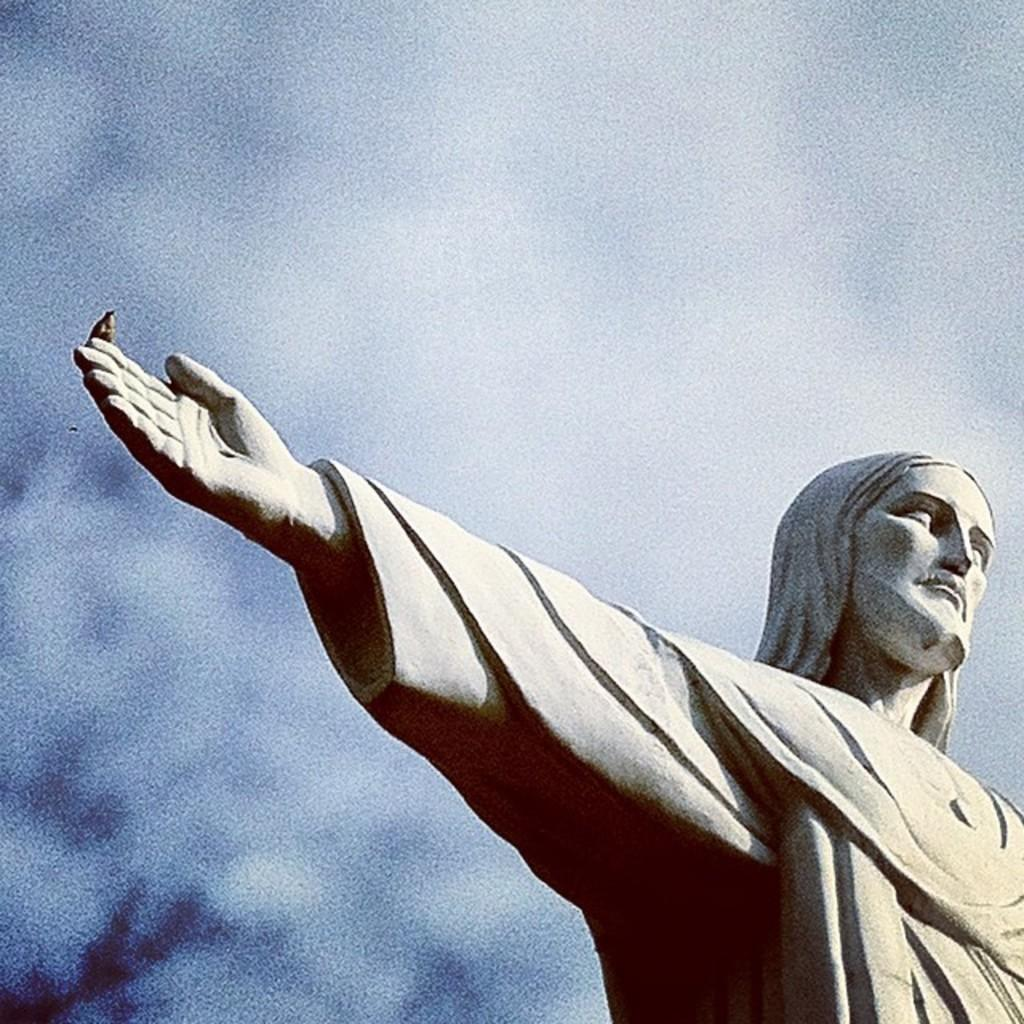What is the main subject of the picture? The main subject of the picture is a statue. What is the bird doing in the picture? A small bird is sitting on the statue's hand. How would you describe the weather in the picture? The sky is clear, which suggests good weather. What color is the sofa in the picture? There is no sofa present in the image. How many people are resting on the statue in the picture? There are no people resting on the statue in the image; only a small bird is sitting on the statue's hand. 